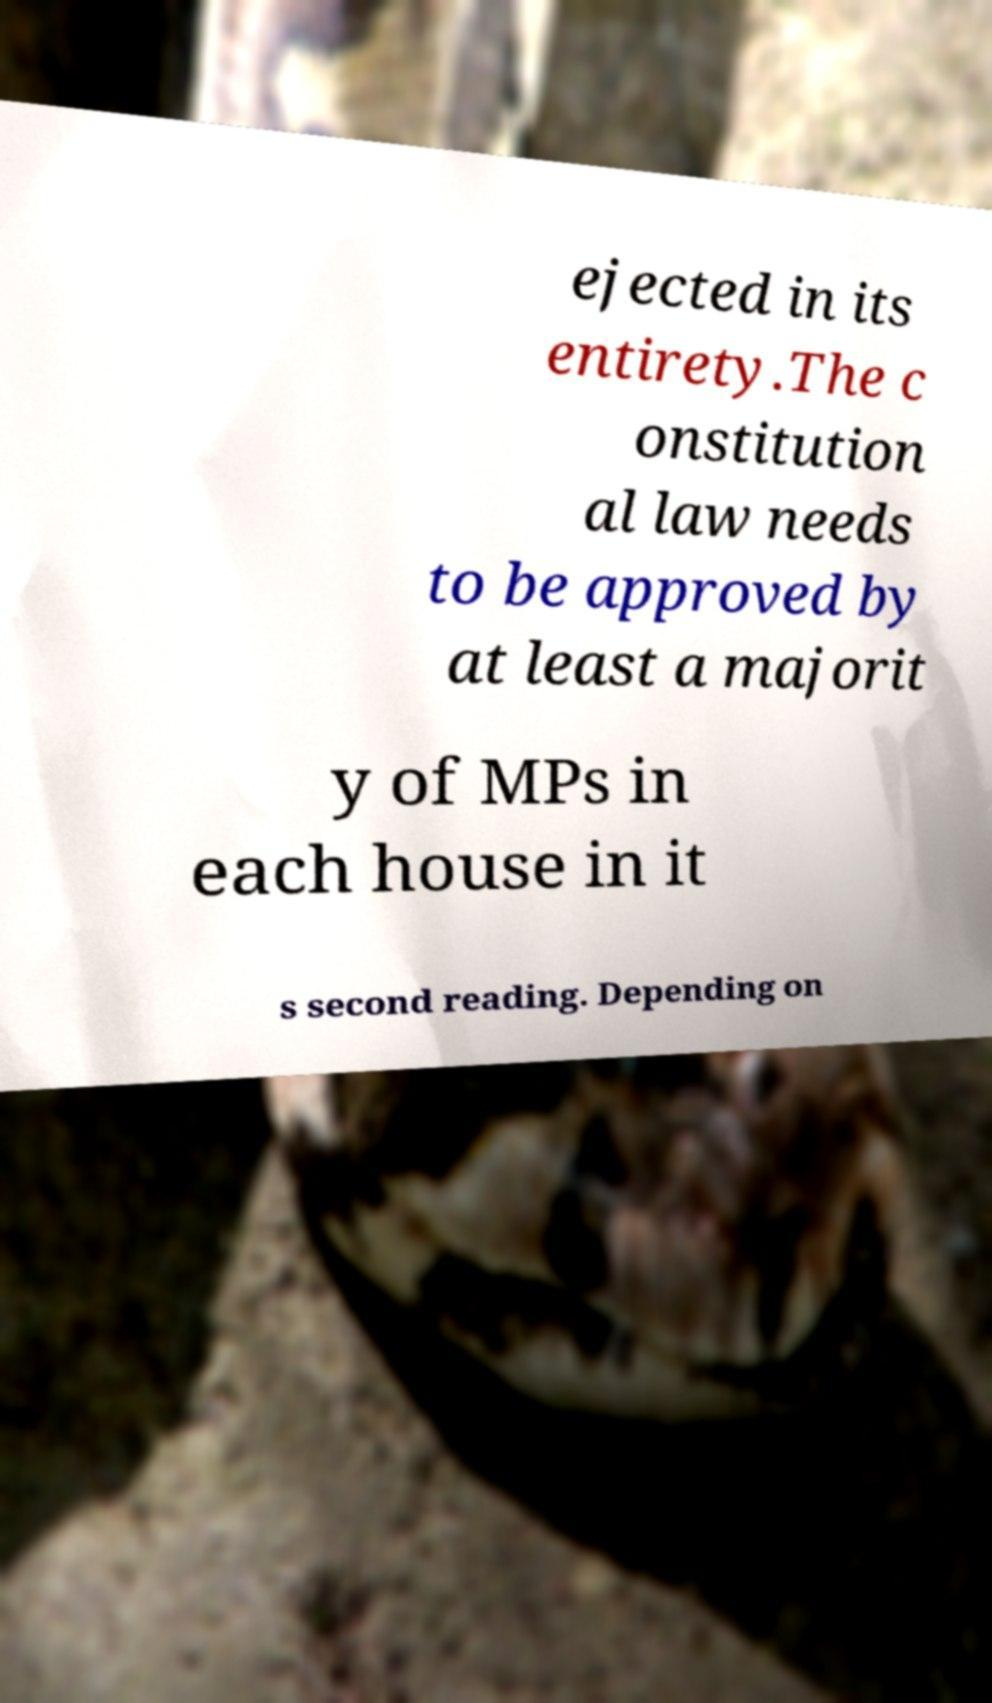Could you assist in decoding the text presented in this image and type it out clearly? ejected in its entirety.The c onstitution al law needs to be approved by at least a majorit y of MPs in each house in it s second reading. Depending on 